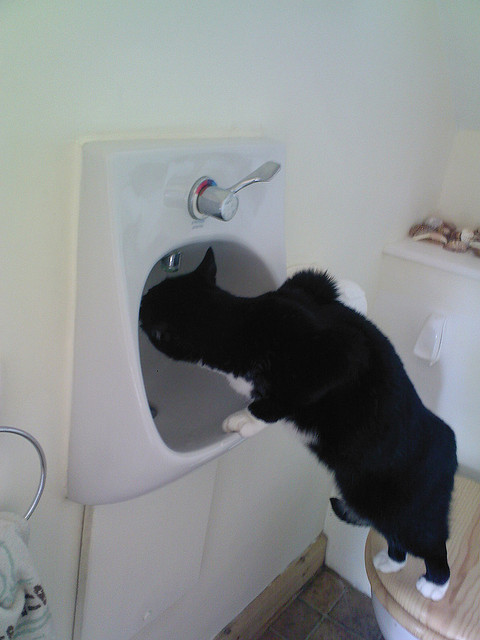<image>What is the cat playing with? It is unknown what the cat is playing with. It might be a sink or urinal. What is the cat playing with? It is ambiguous what the cat is playing with. It can be seen playing with a washer, peeping into something, or playing with water in the sink or urinal. 